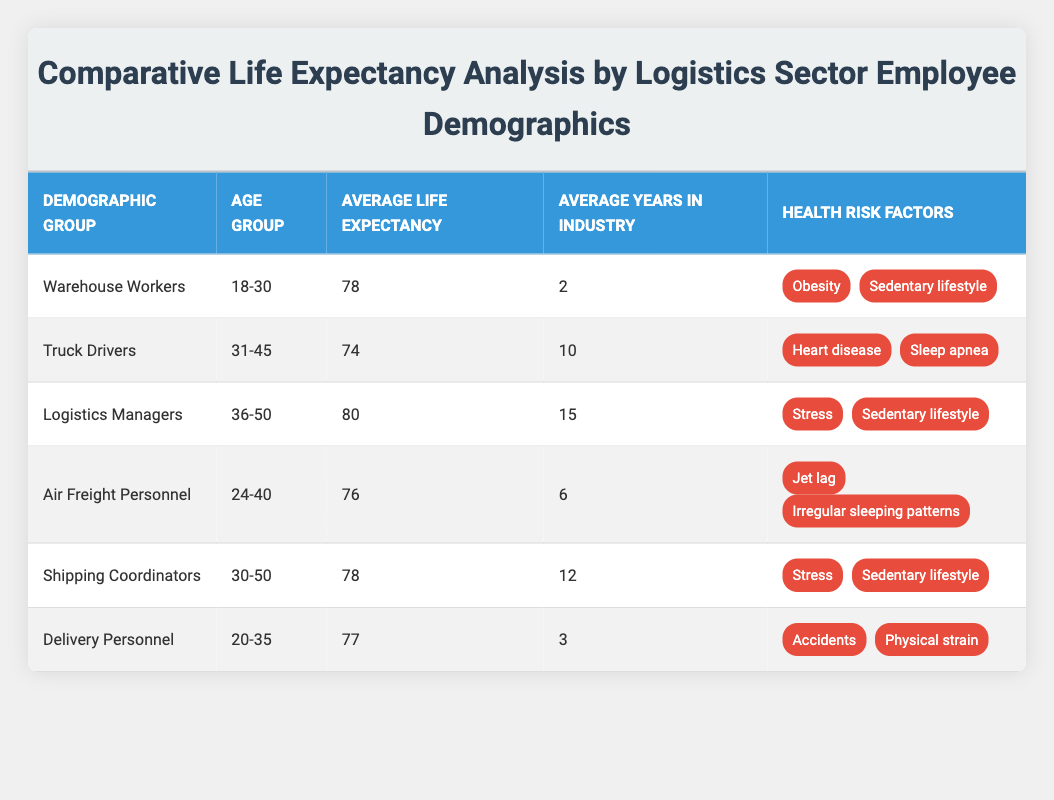What is the average life expectancy of Warehouse Workers? According to the table, Warehouse Workers have an average life expectancy of 78 years.
Answer: 78 Which demographic group has the longest average life expectancy? The table shows that Logistics Managers have the longest average life expectancy at 80 years.
Answer: 80 Do Delivery Personnel have more or fewer average years in the industry compared to Air Freight Personnel? Delivery Personnel have 3 average years in the industry, while Air Freight Personnel have 6. Since 3 is fewer than 6, the answer is fewer.
Answer: Fewer What is the average life expectancy of Truck Drivers in comparison to Air Freight Personnel? Truck Drivers have an average life expectancy of 74 years, while Air Freight Personnel have an average life expectancy of 76 years. Thus, Air Freight Personnel live 2 years longer on average than Truck Drivers.
Answer: Air Freight Personnel live 2 years longer Which demographic group has both Stress and Sedentary lifestyle as health risk factors? The table lists Logistics Managers and Shipping Coordinators as demographic groups with Stress and Sedentary lifestyle as their health risk factors.
Answer: Logistics Managers and Shipping Coordinators What is the total average life expectancy of Warehouse Workers, Truck Drivers, and Delivery Personnel combined? First, sum their average life expectancies: 78 (Warehouse Workers) + 74 (Truck Drivers) + 77 (Delivery Personnel) = 229. Then, there are 3 groups, so the average is 229/3 = approximately 76.33 years.
Answer: Approximately 76.33 Are the average years in the industry for Logistics Managers greater than the average years for Truck Drivers? Logistics Managers have 15 average years in the industry, while Truck Drivers have 10. Since 15 is greater than 10, the answer is yes.
Answer: Yes What is the difference in average life expectancy between Shipping Coordinators and Truck Drivers? Shipping Coordinators' average life expectancy is 78 years, and Truck Drivers' is 74 years. The difference is 78 - 74 = 4 years.
Answer: 4 years How many health risk factors do Delivery Personnel have? The health risk factors listed for Delivery Personnel are Accidents and Physical strain, which totals to 2 health risk factors.
Answer: 2 